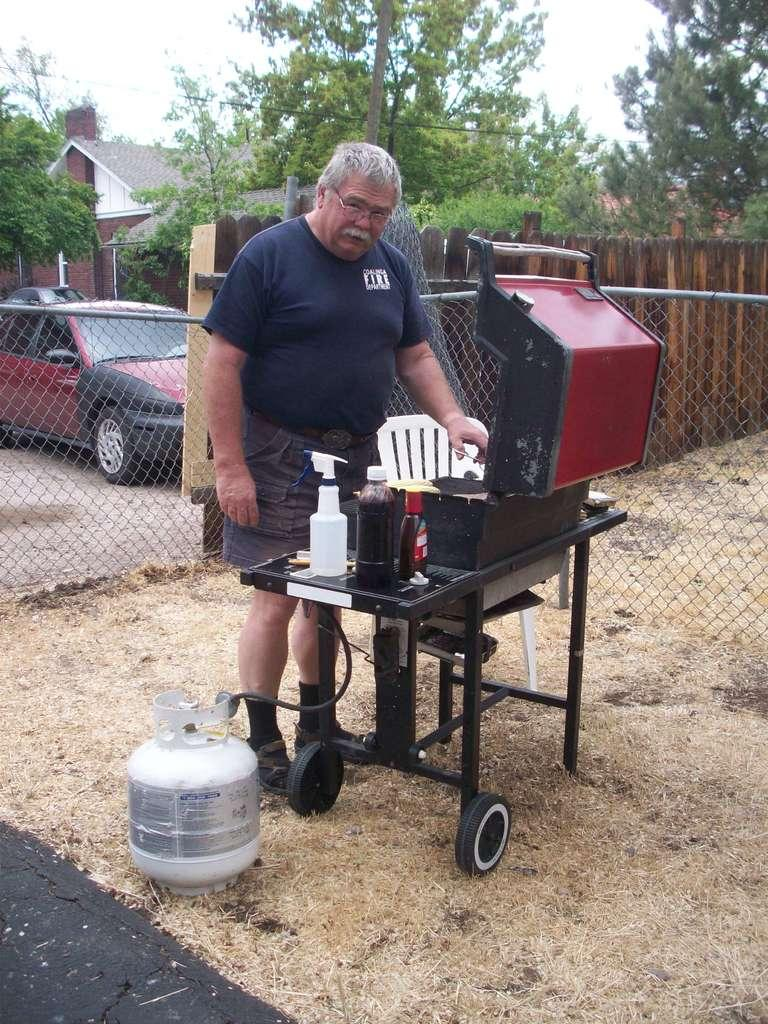What is the person in the image doing? The person is standing at the table in the image. What objects can be seen on the table? There are bottles and a spray on the table. What can be seen in the background of the image? There is fencing, a building, trees, a car, and the sky visible in the background of the image. What flavor of lip balm is the person using in the image? There is no lip balm present in the image, and therefore no flavor can be determined. 